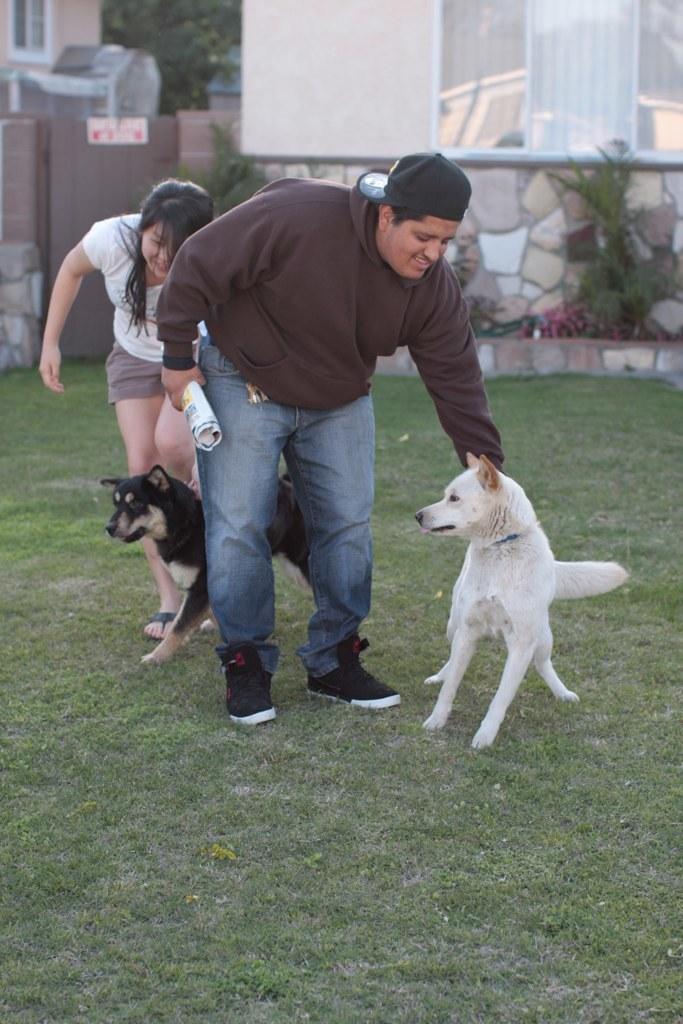How would you summarize this image in a sentence or two? In this image, we can see persons and dogs. The person who is in the middle of the image holding a paper with his hand. There is a wall in the top right of the image. 